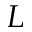Convert formula to latex. <formula><loc_0><loc_0><loc_500><loc_500>L</formula> 